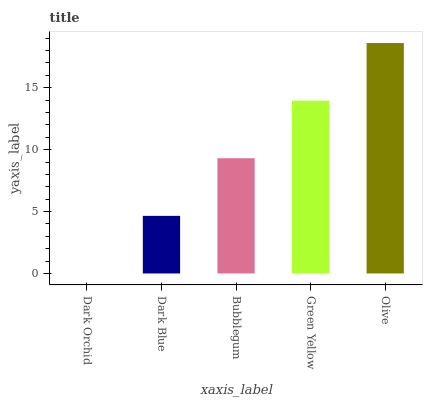Is Dark Orchid the minimum?
Answer yes or no. Yes. Is Olive the maximum?
Answer yes or no. Yes. Is Dark Blue the minimum?
Answer yes or no. No. Is Dark Blue the maximum?
Answer yes or no. No. Is Dark Blue greater than Dark Orchid?
Answer yes or no. Yes. Is Dark Orchid less than Dark Blue?
Answer yes or no. Yes. Is Dark Orchid greater than Dark Blue?
Answer yes or no. No. Is Dark Blue less than Dark Orchid?
Answer yes or no. No. Is Bubblegum the high median?
Answer yes or no. Yes. Is Bubblegum the low median?
Answer yes or no. Yes. Is Olive the high median?
Answer yes or no. No. Is Olive the low median?
Answer yes or no. No. 